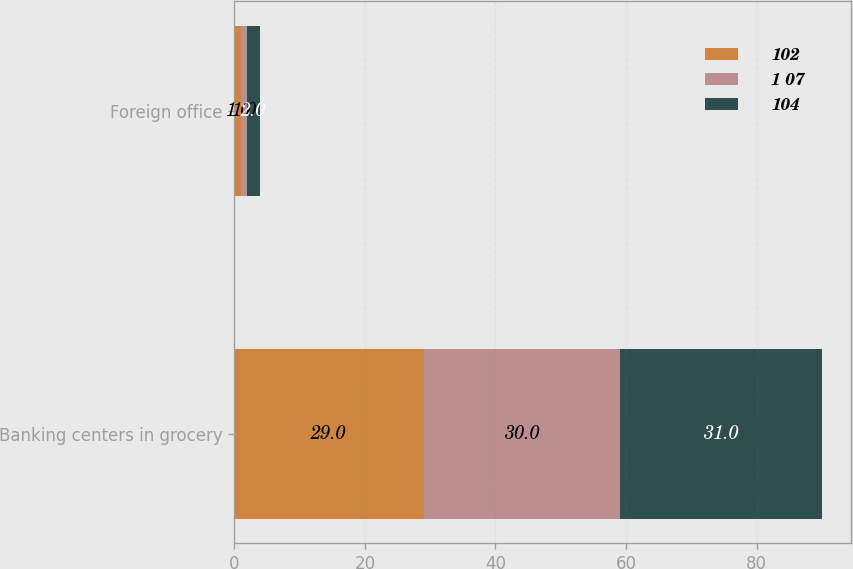<chart> <loc_0><loc_0><loc_500><loc_500><stacked_bar_chart><ecel><fcel>Banking centers in grocery<fcel>Foreign office<nl><fcel>102<fcel>29<fcel>1<nl><fcel>1 07<fcel>30<fcel>1<nl><fcel>104<fcel>31<fcel>2<nl></chart> 